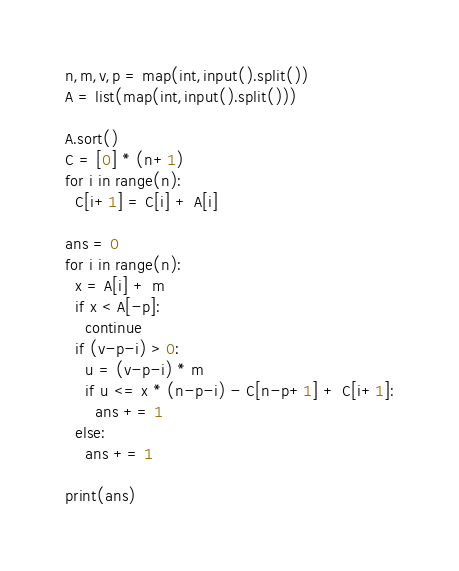<code> <loc_0><loc_0><loc_500><loc_500><_Python_>n,m,v,p = map(int,input().split())
A = list(map(int,input().split()))

A.sort()
C = [0] * (n+1)
for i in range(n):
  C[i+1] = C[i] + A[i]
  
ans = 0
for i in range(n):
  x = A[i] + m
  if x < A[-p]:
    continue
  if (v-p-i) > 0:
    u = (v-p-i) * m
    if u <= x * (n-p-i) - C[n-p+1] + C[i+1]:
      ans += 1
  else:
    ans += 1
    
print(ans)</code> 